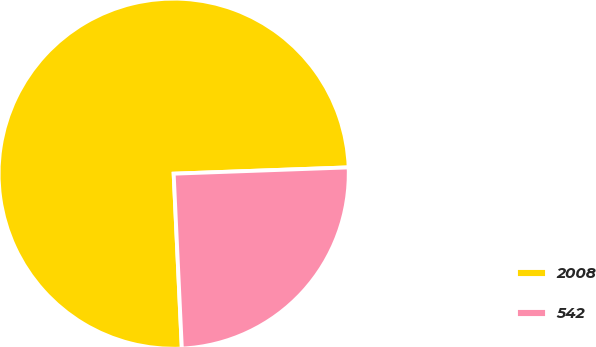Convert chart. <chart><loc_0><loc_0><loc_500><loc_500><pie_chart><fcel>2008<fcel>542<nl><fcel>75.17%<fcel>24.83%<nl></chart> 